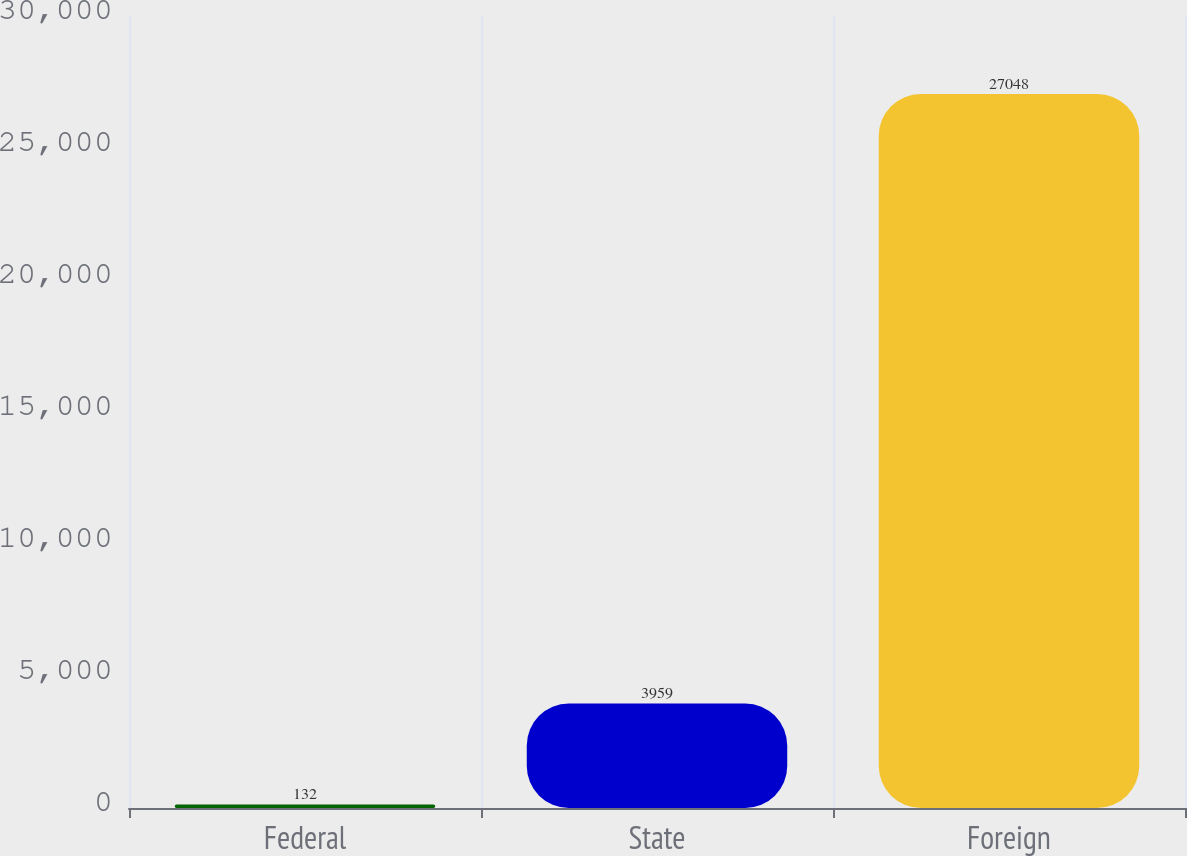Convert chart to OTSL. <chart><loc_0><loc_0><loc_500><loc_500><bar_chart><fcel>Federal<fcel>State<fcel>Foreign<nl><fcel>132<fcel>3959<fcel>27048<nl></chart> 